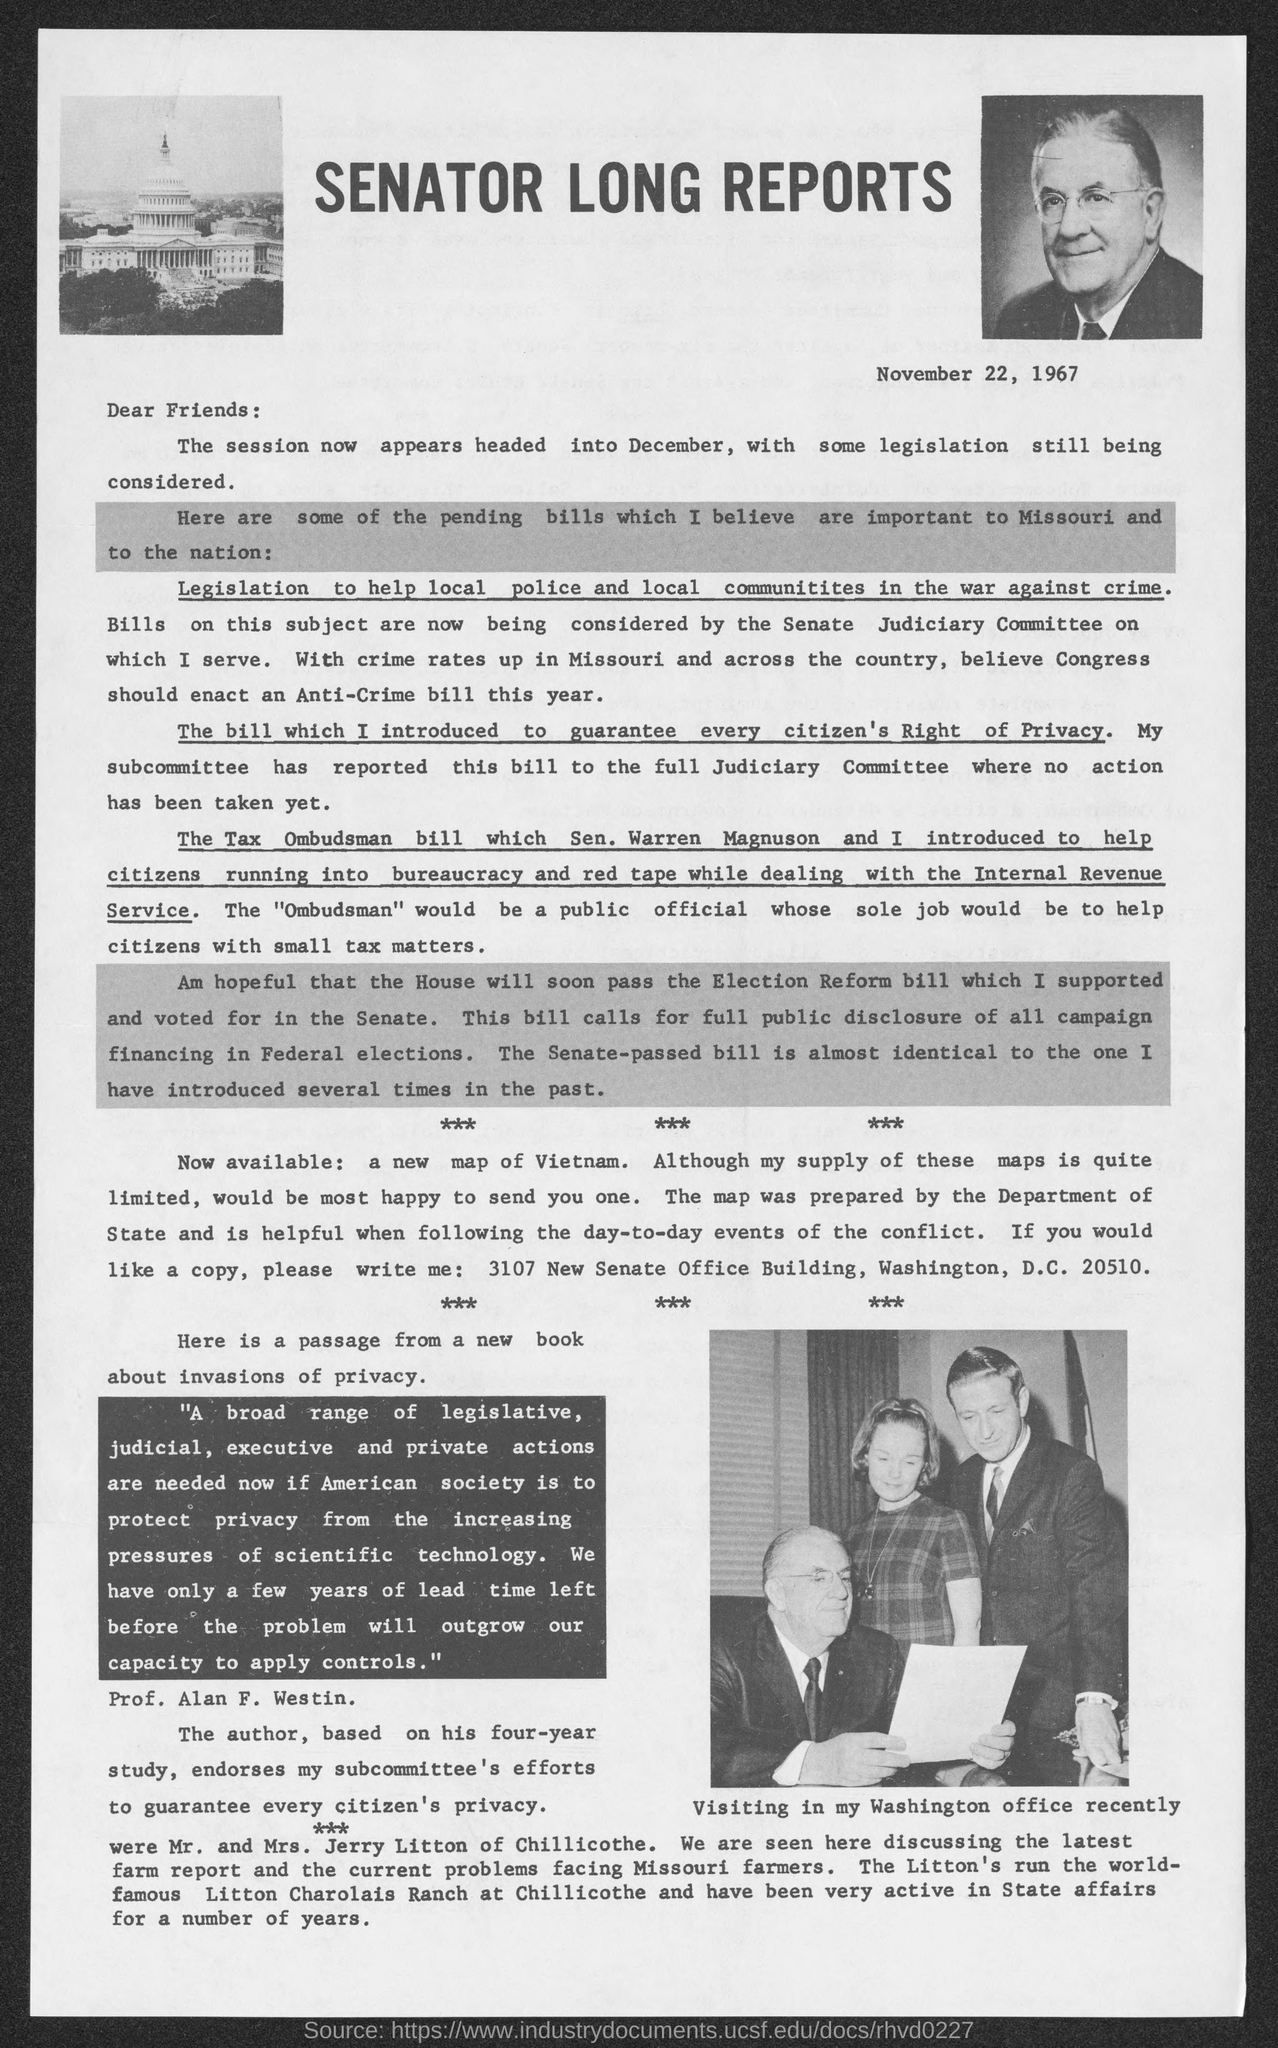Identify some key points in this picture. The first underlined word in the passage is "Legislation. The title of this letter is 'Senator Long's Report.' The senator recently visited the Washington office. This letter or report was written on November 22, 1967. The passage is addressed to friends. 